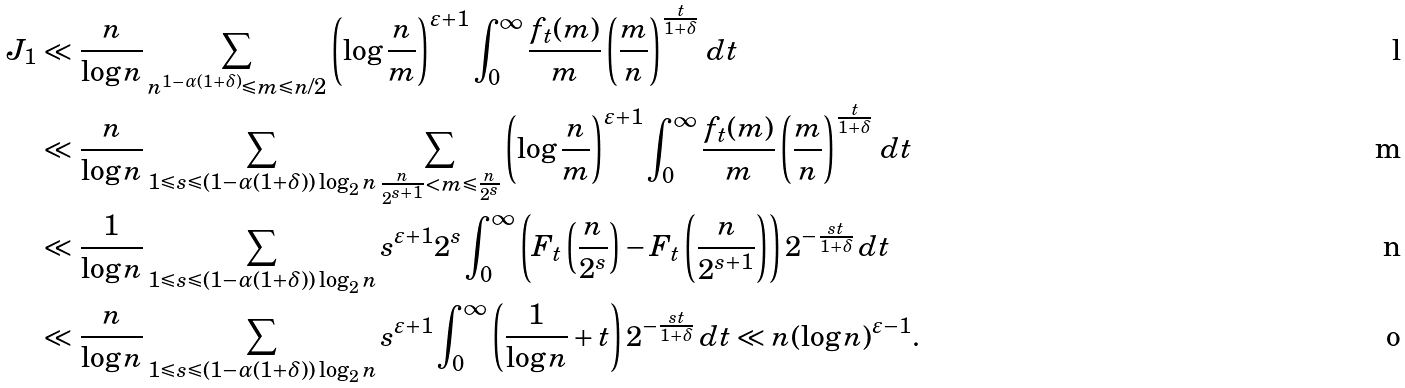Convert formula to latex. <formula><loc_0><loc_0><loc_500><loc_500>J _ { 1 } & \ll \frac { n } { \log n } \sum _ { n ^ { 1 - \alpha ( 1 + \delta ) } \leqslant m \leqslant n / 2 } \left ( \log \frac { n } { m } \right ) ^ { \varepsilon + 1 } \int _ { 0 } ^ { \infty } \frac { f _ { t } ( m ) } { m } \left ( \frac { m } { n } \right ) ^ { \frac { t } { 1 + \delta } } \, d t \\ & \ll \frac { n } { \log n } \sum _ { 1 \leqslant s \leqslant ( 1 - \alpha ( 1 + \delta ) ) \log _ { 2 } n } \sum _ { \frac { n } { 2 ^ { s + 1 } } < m \leqslant \frac { n } { 2 ^ { s } } } \left ( \log \frac { n } { m } \right ) ^ { \varepsilon + 1 } \int _ { 0 } ^ { \infty } \frac { f _ { t } ( m ) } { m } \left ( \frac { m } { n } \right ) ^ { \frac { t } { 1 + \delta } } \, d t \\ & \ll \frac { 1 } { \log n } \sum _ { 1 \leqslant s \leqslant ( 1 - \alpha ( 1 + \delta ) ) \log _ { 2 } n } s ^ { \varepsilon + 1 } 2 ^ { s } \int _ { 0 } ^ { \infty } \left ( F _ { t } \left ( \frac { n } { 2 ^ { s } } \right ) - F _ { t } \left ( \frac { n } { 2 ^ { s + 1 } } \right ) \right ) 2 ^ { - \frac { s t } { 1 + \delta } } \, d t \\ & \ll \frac { n } { \log n } \sum _ { 1 \leqslant s \leqslant ( 1 - \alpha ( 1 + \delta ) ) \log _ { 2 } n } s ^ { \varepsilon + 1 } \int _ { 0 } ^ { \infty } \left ( \frac { 1 } { \log n } + t \right ) 2 ^ { - \frac { s t } { 1 + \delta } } \, d t \ll n ( \log n ) ^ { \varepsilon - 1 } .</formula> 